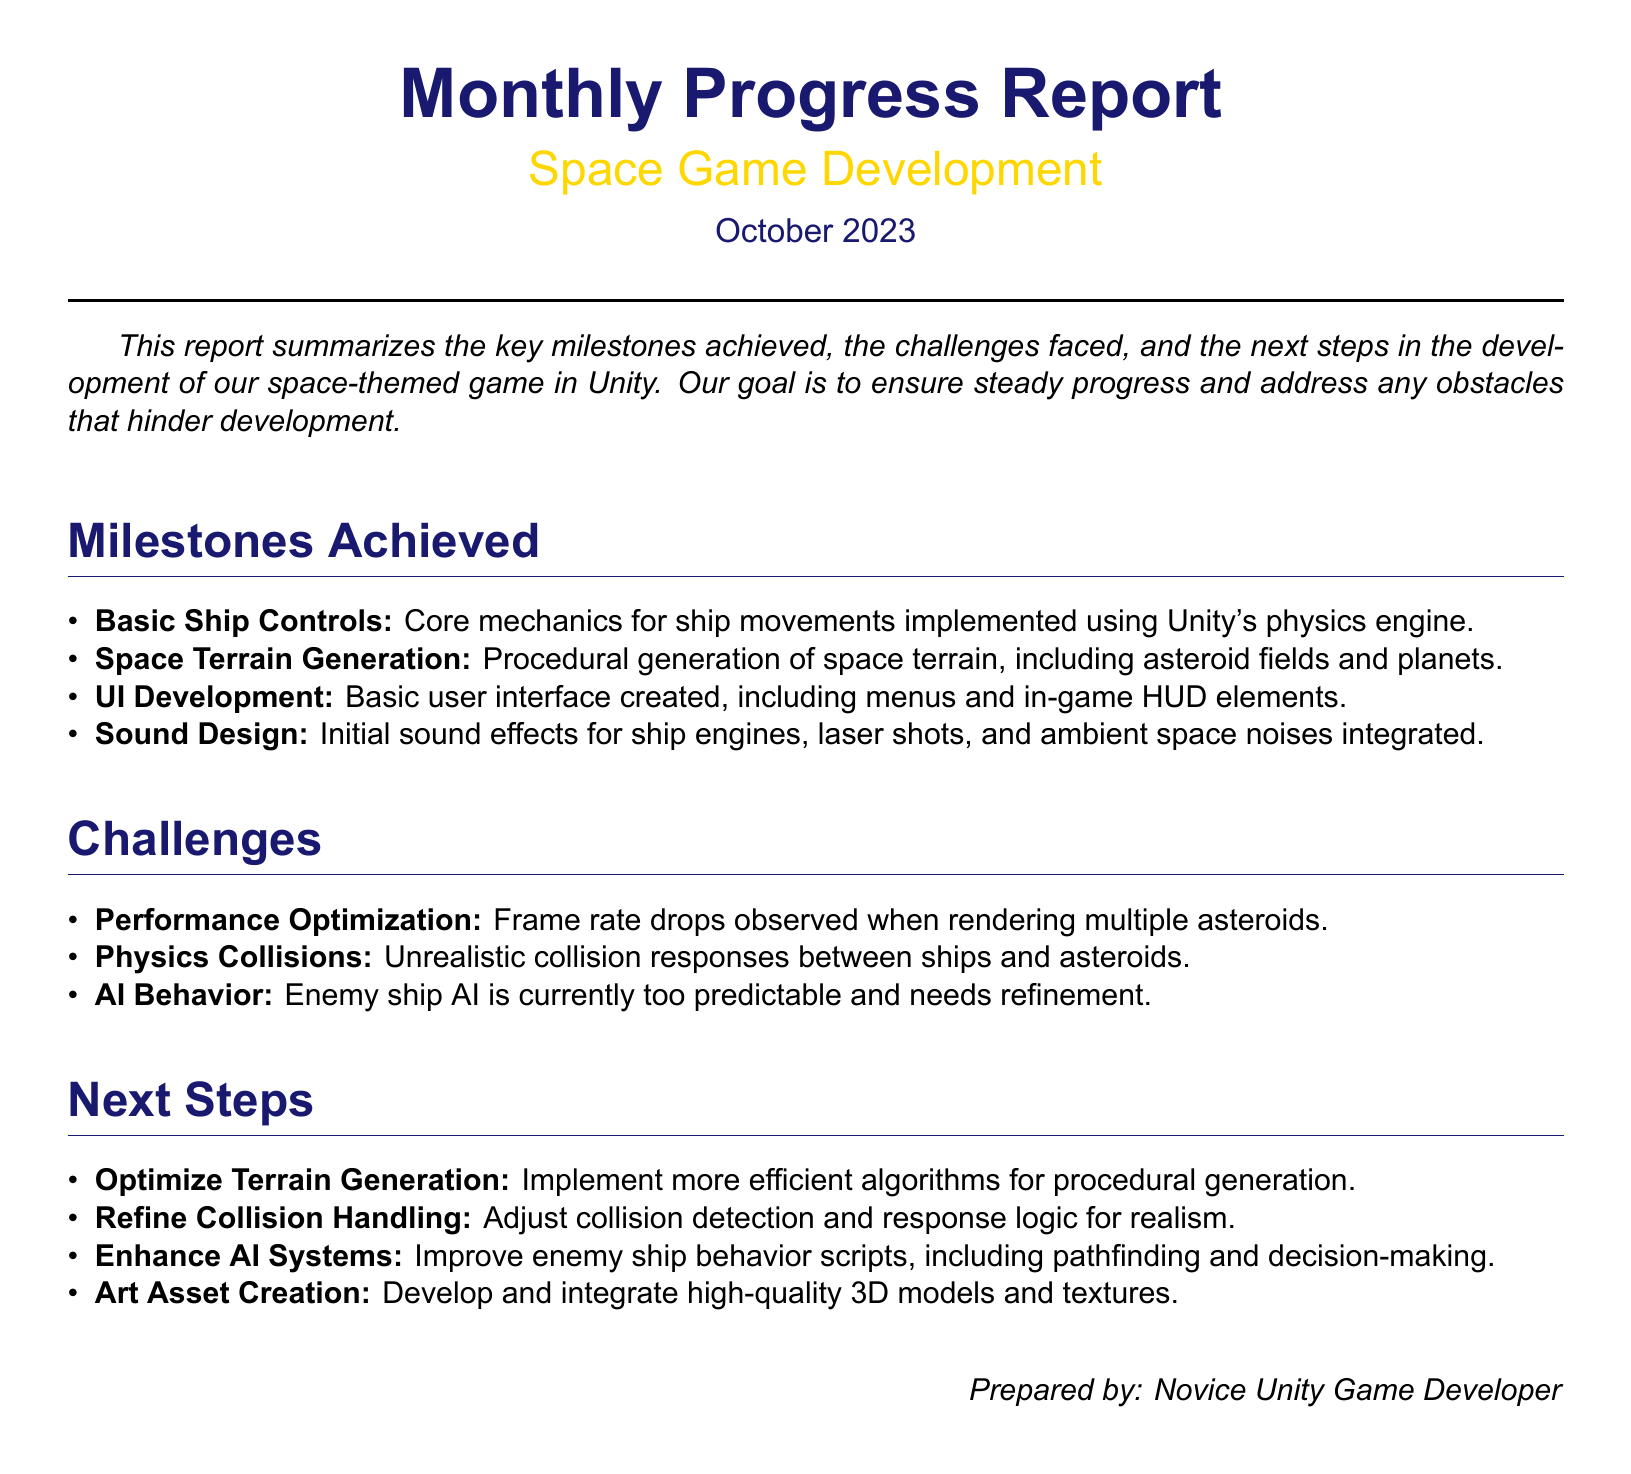What is the title of the report? The title of the report can be found prominently at the top of the document.
Answer: Monthly Progress Report What date is the report for? The date of the report is specified at the top in the date section.
Answer: October 2023 What is one of the milestones achieved? This information can be found in the milestones section of the report.
Answer: Basic Ship Controls What challenge is related to AI behavior? Challenges related to AI behavior are listed in the challenges section.
Answer: Enemy ship AI is currently too predictable What is the next step regarding terrain generation? The next steps include specific actions to improve different areas of the game.
Answer: Optimize Terrain Generation How many milestones are listed in the report? The total milestones presented can be counted from the milestones section.
Answer: Four What is the primary goal mentioned in the report? The goal is stated in the introduction section to summarize the progress.
Answer: Ensure steady progress Who prepared the report? The name of the person who prepared the report is mentioned at the end.
Answer: Novice Unity Game Developer 